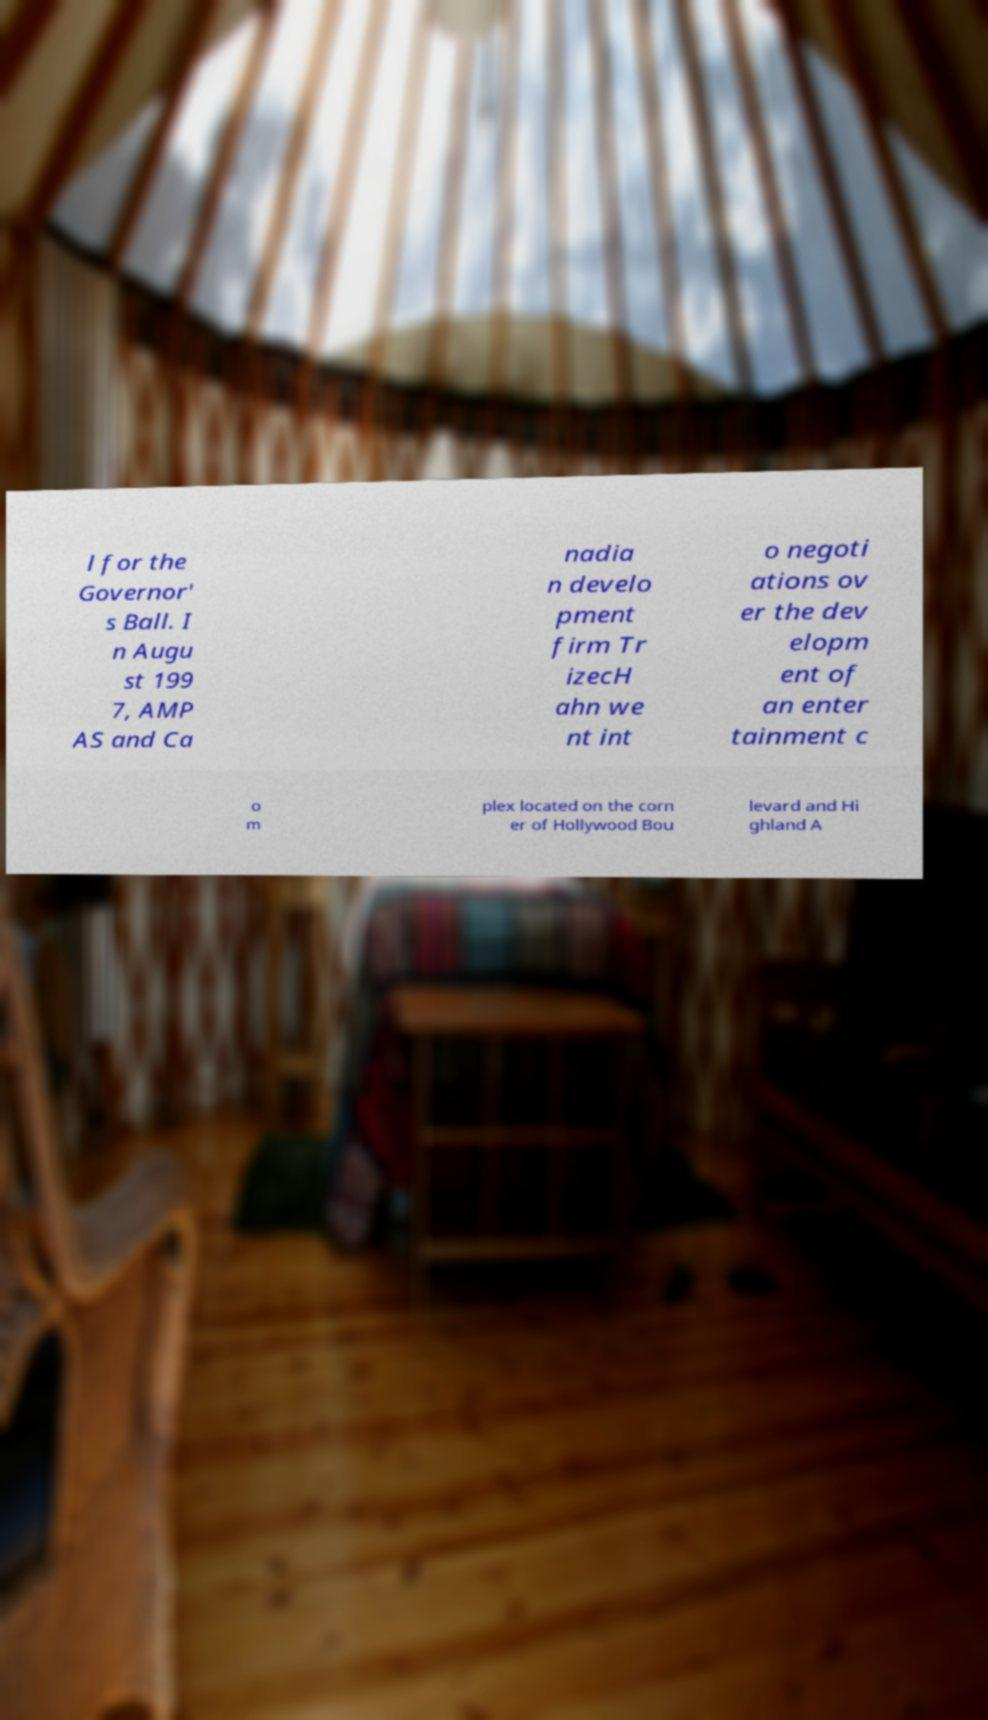Could you extract and type out the text from this image? l for the Governor' s Ball. I n Augu st 199 7, AMP AS and Ca nadia n develo pment firm Tr izecH ahn we nt int o negoti ations ov er the dev elopm ent of an enter tainment c o m plex located on the corn er of Hollywood Bou levard and Hi ghland A 